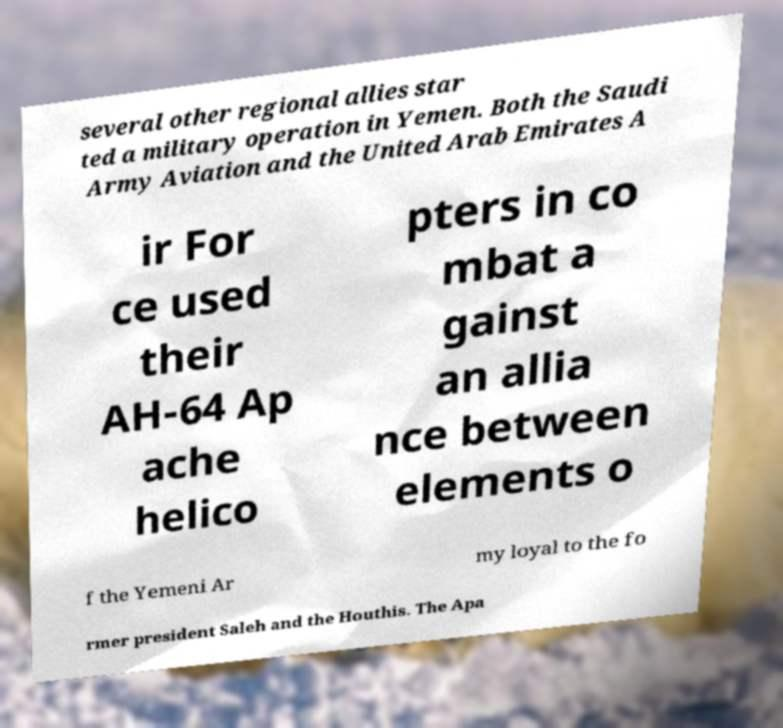Please identify and transcribe the text found in this image. several other regional allies star ted a military operation in Yemen. Both the Saudi Army Aviation and the United Arab Emirates A ir For ce used their AH-64 Ap ache helico pters in co mbat a gainst an allia nce between elements o f the Yemeni Ar my loyal to the fo rmer president Saleh and the Houthis. The Apa 